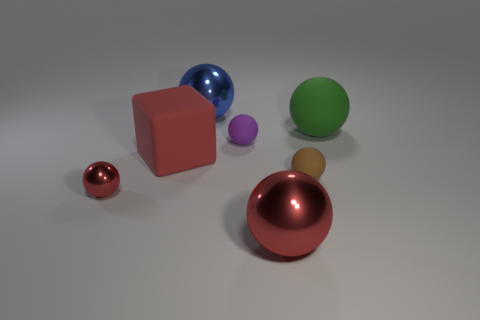What could be a possible use for these objects if they were real? If these objects were real, they could serve various purposes. The balls might be used as decorative elements or toys, given their appealing colors and shiny surfaces. The larger spheres could be part of kinetic sculptures or used in educational settings to demonstrate principles of geometry and physics. The blocks might be children's building toys, paperweights, or educational aids for teaching about volumes and spatial relationships. 